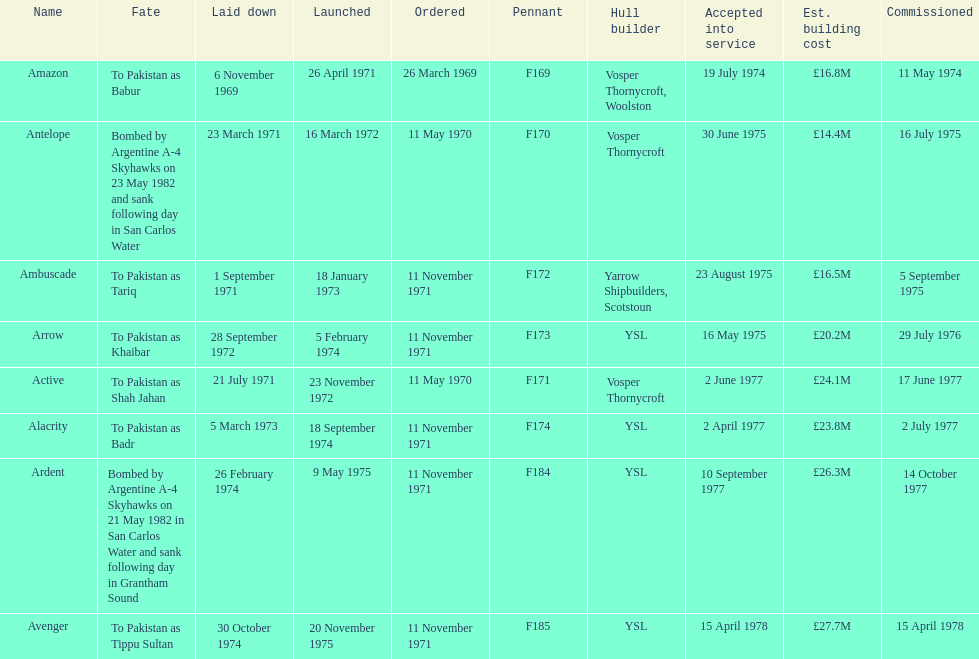How many boats costed less than £20m to build? 3. 